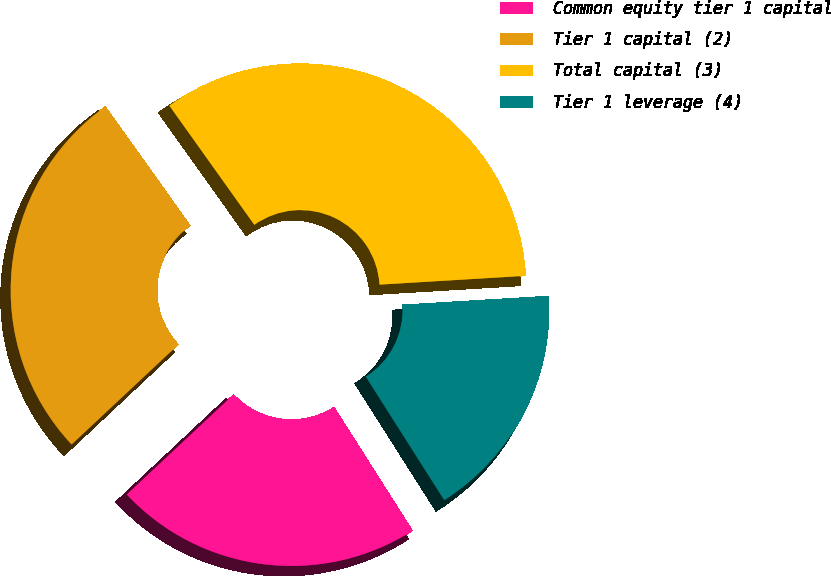Convert chart. <chart><loc_0><loc_0><loc_500><loc_500><pie_chart><fcel>Common equity tier 1 capital<fcel>Tier 1 capital (2)<fcel>Total capital (3)<fcel>Tier 1 leverage (4)<nl><fcel>22.03%<fcel>27.12%<fcel>33.9%<fcel>16.95%<nl></chart> 